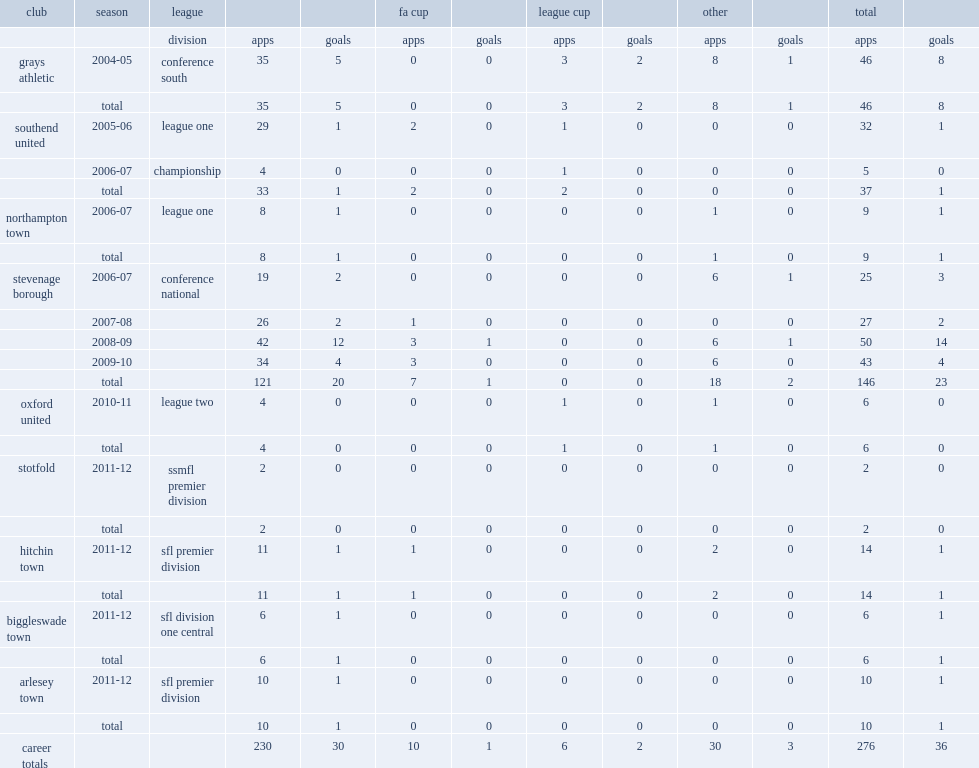How many goals did cole score for the stevenage borough totally. 23.0. 